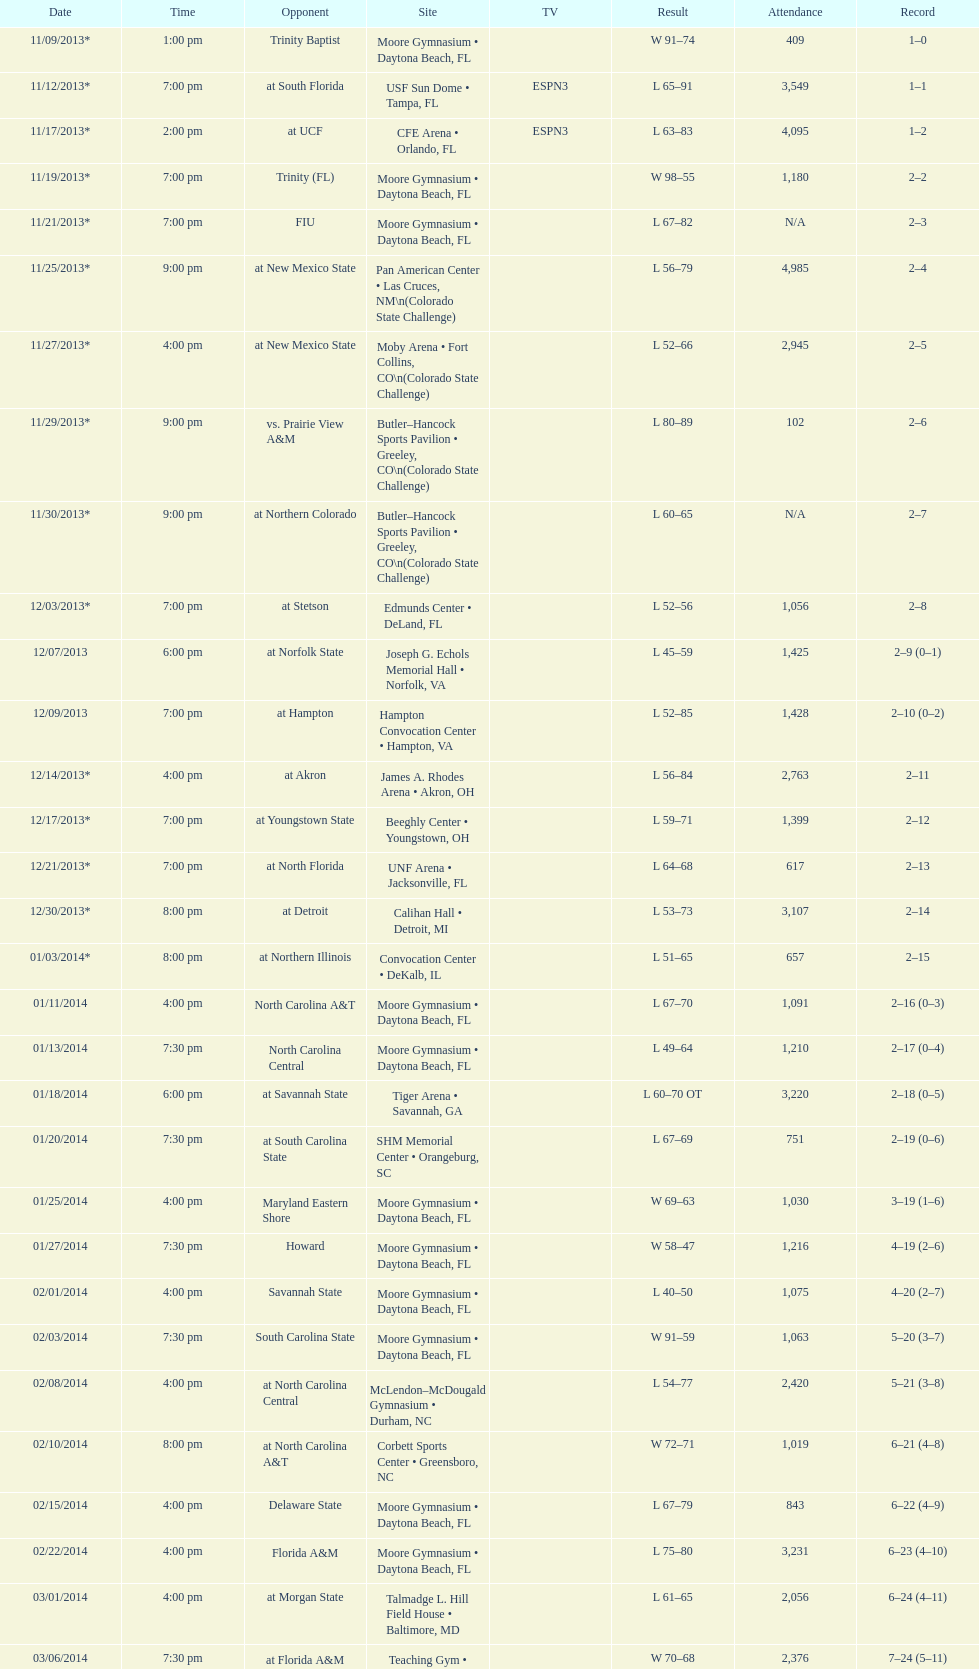Help me parse the entirety of this table. {'header': ['Date', 'Time', 'Opponent', 'Site', 'TV', 'Result', 'Attendance', 'Record'], 'rows': [['11/09/2013*', '1:00 pm', 'Trinity Baptist', 'Moore Gymnasium • Daytona Beach, FL', '', 'W\xa091–74', '409', '1–0'], ['11/12/2013*', '7:00 pm', 'at\xa0South Florida', 'USF Sun Dome • Tampa, FL', 'ESPN3', 'L\xa065–91', '3,549', '1–1'], ['11/17/2013*', '2:00 pm', 'at\xa0UCF', 'CFE Arena • Orlando, FL', 'ESPN3', 'L\xa063–83', '4,095', '1–2'], ['11/19/2013*', '7:00 pm', 'Trinity (FL)', 'Moore Gymnasium • Daytona Beach, FL', '', 'W\xa098–55', '1,180', '2–2'], ['11/21/2013*', '7:00 pm', 'FIU', 'Moore Gymnasium • Daytona Beach, FL', '', 'L\xa067–82', 'N/A', '2–3'], ['11/25/2013*', '9:00 pm', 'at\xa0New Mexico State', 'Pan American Center • Las Cruces, NM\\n(Colorado State Challenge)', '', 'L\xa056–79', '4,985', '2–4'], ['11/27/2013*', '4:00 pm', 'at\xa0New Mexico State', 'Moby Arena • Fort Collins, CO\\n(Colorado State Challenge)', '', 'L\xa052–66', '2,945', '2–5'], ['11/29/2013*', '9:00 pm', 'vs.\xa0Prairie View A&M', 'Butler–Hancock Sports Pavilion • Greeley, CO\\n(Colorado State Challenge)', '', 'L\xa080–89', '102', '2–6'], ['11/30/2013*', '9:00 pm', 'at\xa0Northern Colorado', 'Butler–Hancock Sports Pavilion • Greeley, CO\\n(Colorado State Challenge)', '', 'L\xa060–65', 'N/A', '2–7'], ['12/03/2013*', '7:00 pm', 'at\xa0Stetson', 'Edmunds Center • DeLand, FL', '', 'L\xa052–56', '1,056', '2–8'], ['12/07/2013', '6:00 pm', 'at\xa0Norfolk State', 'Joseph G. Echols Memorial Hall • Norfolk, VA', '', 'L\xa045–59', '1,425', '2–9 (0–1)'], ['12/09/2013', '7:00 pm', 'at\xa0Hampton', 'Hampton Convocation Center • Hampton, VA', '', 'L\xa052–85', '1,428', '2–10 (0–2)'], ['12/14/2013*', '4:00 pm', 'at\xa0Akron', 'James A. Rhodes Arena • Akron, OH', '', 'L\xa056–84', '2,763', '2–11'], ['12/17/2013*', '7:00 pm', 'at\xa0Youngstown State', 'Beeghly Center • Youngstown, OH', '', 'L\xa059–71', '1,399', '2–12'], ['12/21/2013*', '7:00 pm', 'at\xa0North Florida', 'UNF Arena • Jacksonville, FL', '', 'L\xa064–68', '617', '2–13'], ['12/30/2013*', '8:00 pm', 'at\xa0Detroit', 'Calihan Hall • Detroit, MI', '', 'L\xa053–73', '3,107', '2–14'], ['01/03/2014*', '8:00 pm', 'at\xa0Northern Illinois', 'Convocation Center • DeKalb, IL', '', 'L\xa051–65', '657', '2–15'], ['01/11/2014', '4:00 pm', 'North Carolina A&T', 'Moore Gymnasium • Daytona Beach, FL', '', 'L\xa067–70', '1,091', '2–16 (0–3)'], ['01/13/2014', '7:30 pm', 'North Carolina Central', 'Moore Gymnasium • Daytona Beach, FL', '', 'L\xa049–64', '1,210', '2–17 (0–4)'], ['01/18/2014', '6:00 pm', 'at\xa0Savannah State', 'Tiger Arena • Savannah, GA', '', 'L\xa060–70\xa0OT', '3,220', '2–18 (0–5)'], ['01/20/2014', '7:30 pm', 'at\xa0South Carolina State', 'SHM Memorial Center • Orangeburg, SC', '', 'L\xa067–69', '751', '2–19 (0–6)'], ['01/25/2014', '4:00 pm', 'Maryland Eastern Shore', 'Moore Gymnasium • Daytona Beach, FL', '', 'W\xa069–63', '1,030', '3–19 (1–6)'], ['01/27/2014', '7:30 pm', 'Howard', 'Moore Gymnasium • Daytona Beach, FL', '', 'W\xa058–47', '1,216', '4–19 (2–6)'], ['02/01/2014', '4:00 pm', 'Savannah State', 'Moore Gymnasium • Daytona Beach, FL', '', 'L\xa040–50', '1,075', '4–20 (2–7)'], ['02/03/2014', '7:30 pm', 'South Carolina State', 'Moore Gymnasium • Daytona Beach, FL', '', 'W\xa091–59', '1,063', '5–20 (3–7)'], ['02/08/2014', '4:00 pm', 'at\xa0North Carolina Central', 'McLendon–McDougald Gymnasium • Durham, NC', '', 'L\xa054–77', '2,420', '5–21 (3–8)'], ['02/10/2014', '8:00 pm', 'at\xa0North Carolina A&T', 'Corbett Sports Center • Greensboro, NC', '', 'W\xa072–71', '1,019', '6–21 (4–8)'], ['02/15/2014', '4:00 pm', 'Delaware State', 'Moore Gymnasium • Daytona Beach, FL', '', 'L\xa067–79', '843', '6–22 (4–9)'], ['02/22/2014', '4:00 pm', 'Florida A&M', 'Moore Gymnasium • Daytona Beach, FL', '', 'L\xa075–80', '3,231', '6–23 (4–10)'], ['03/01/2014', '4:00 pm', 'at\xa0Morgan State', 'Talmadge L. Hill Field House • Baltimore, MD', '', 'L\xa061–65', '2,056', '6–24 (4–11)'], ['03/06/2014', '7:30 pm', 'at\xa0Florida A&M', 'Teaching Gym • Tallahassee, FL', '', 'W\xa070–68', '2,376', '7–24 (5–11)'], ['03/11/2014', '6:30 pm', 'vs.\xa0Coppin State', 'Norfolk Scope • Norfolk, VA\\n(First round)', '', 'L\xa068–75', '4,658', '7–25']]} Which game had a more significant win, against trinity (fl) or against trinity baptist? Trinity (FL). 